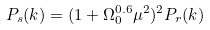Convert formula to latex. <formula><loc_0><loc_0><loc_500><loc_500>P _ { s } ( { k } ) = ( 1 + \Omega _ { 0 } ^ { 0 . 6 } \mu ^ { 2 } ) ^ { 2 } P _ { r } ( k )</formula> 